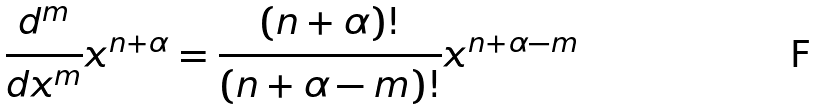<formula> <loc_0><loc_0><loc_500><loc_500>\frac { d ^ { m } } { d x ^ { m } } x ^ { n + \alpha } = \frac { ( n + \alpha ) ! } { ( n + \alpha - m ) ! } x ^ { n + \alpha - m }</formula> 